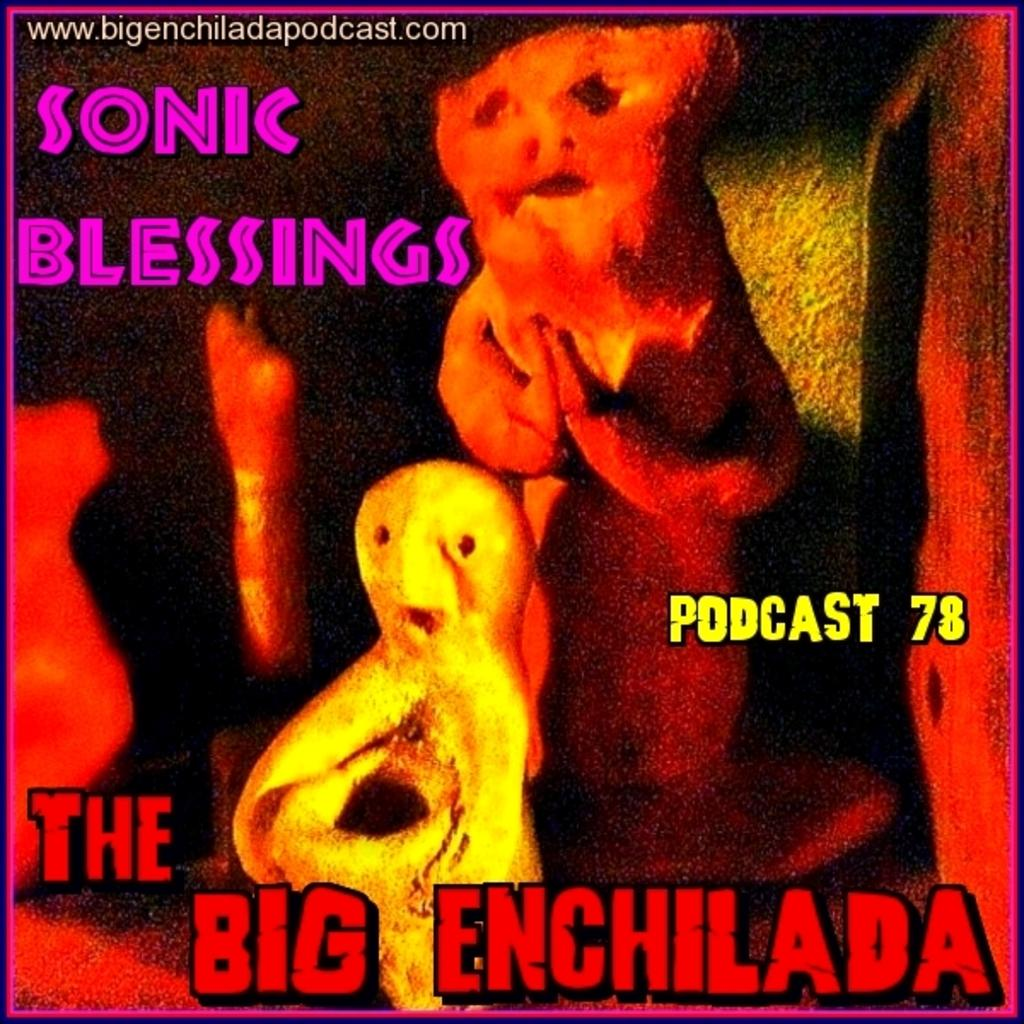<image>
Relay a brief, clear account of the picture shown. A strange poster for The Big Enchilada, podcast 78. 